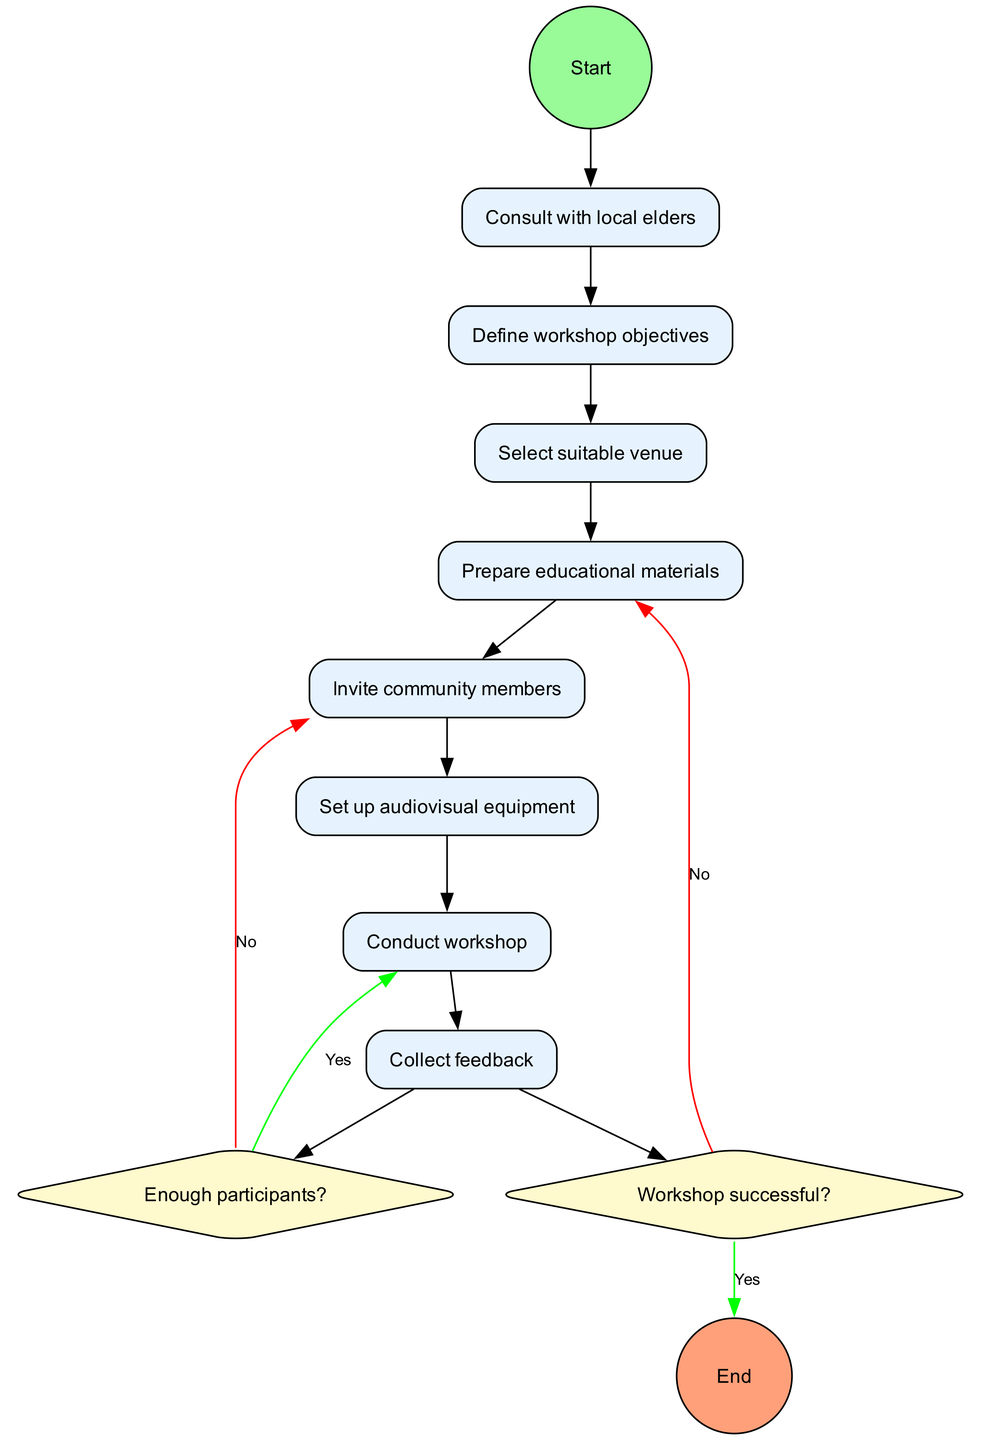What is the first node in the diagram? The first node is labeled "Identify need for workshop", which is directly connected to the start node.
Answer: Identify need for workshop How many activities are there in total? There are eight activities listed in the diagram, which include actions from consultation to feedback collection.
Answer: Eight What is the decision following the last activity? The decision node after the last activity "Conduct workshop" is about "Workshop successful?".
Answer: Workshop successful? What happens if there are not enough participants? If the answer to "Enough participants?" is no, the next step is to "Reschedule and promote further" as indicated by the diagram's flow.
Answer: Reschedule and promote further Which activity comes after inviting community members? After "Invite community members," the next activity is "Set up audiovisual equipment," as shown by the sequential connections in the diagram.
Answer: Set up audiovisual equipment What is the outcome if the workshop is successful? If the "Workshop successful?" decision is answered yes, it leads to the action "Plan follow-up activities" as indicated in the diagram.
Answer: Plan follow-up activities How does the workflow conclude? The workflow concludes with the "Evaluate workshop impact" node, which is the end node of the activity diagram, following all activities and decisions.
Answer: Evaluate workshop impact What color is used for the decision nodes? The decision nodes are filled with a light yellow color, specifically marked as #FFFACD in the diagram.
Answer: Light yellow What occurs in the diagram after conducting the workshop? After conducting the workshop, the diagram shows it leads to the decision node "Workshop successful?".
Answer: Workshop successful? 